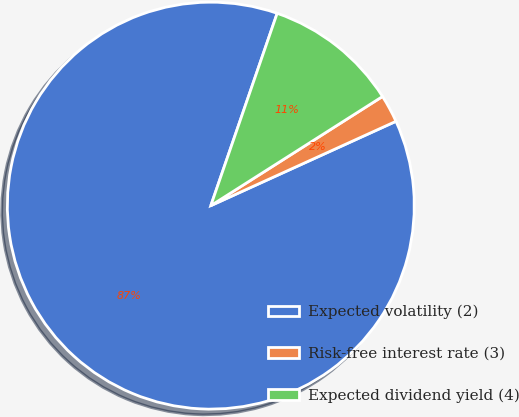<chart> <loc_0><loc_0><loc_500><loc_500><pie_chart><fcel>Expected volatility (2)<fcel>Risk-free interest rate (3)<fcel>Expected dividend yield (4)<nl><fcel>87.09%<fcel>2.21%<fcel>10.7%<nl></chart> 